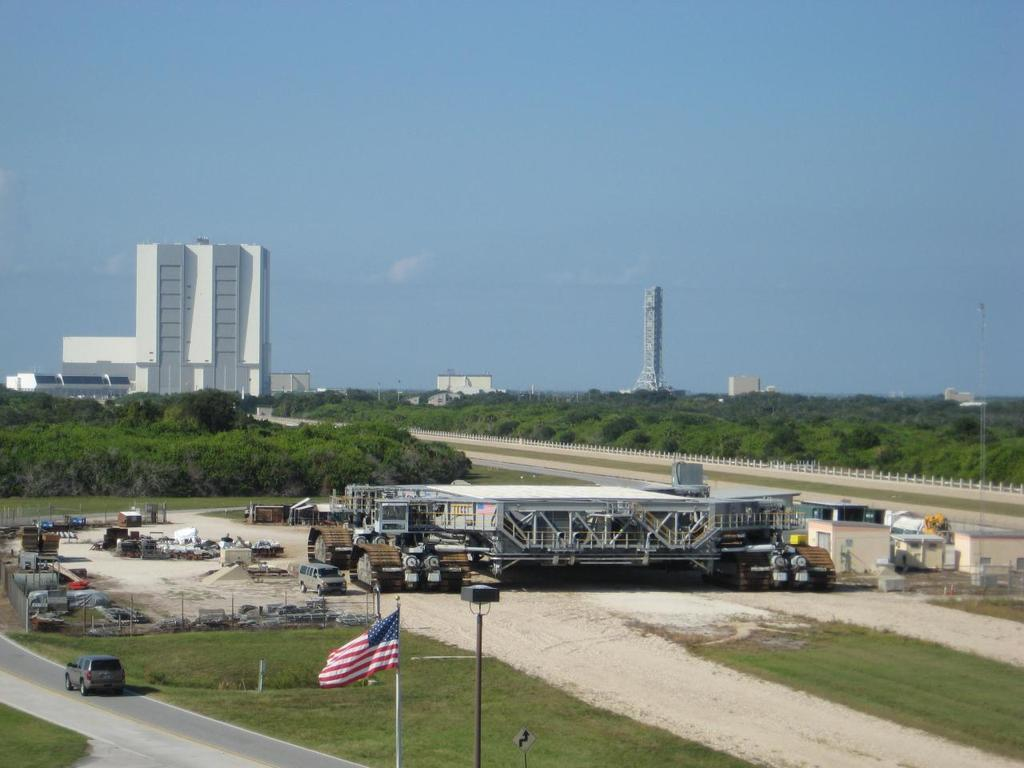What is the main subject of the image? The main subject of the image is a car moving on the road. What else can be seen in the image besides the car? There is a flag, poles, a board, a shed, trees, a tower, buildings, and the sky visible in the image. Can you describe the location of the flag in the image? The flag is not clearly visible in the image, but it is mentioned as one of the objects present. What type of structure is the tower in the image? The image does not provide enough information to determine the type of tower. What color is the pen used by the driver of the car in the image? There is no pen or driver mentioned in the image, so it is not possible to answer that question. 